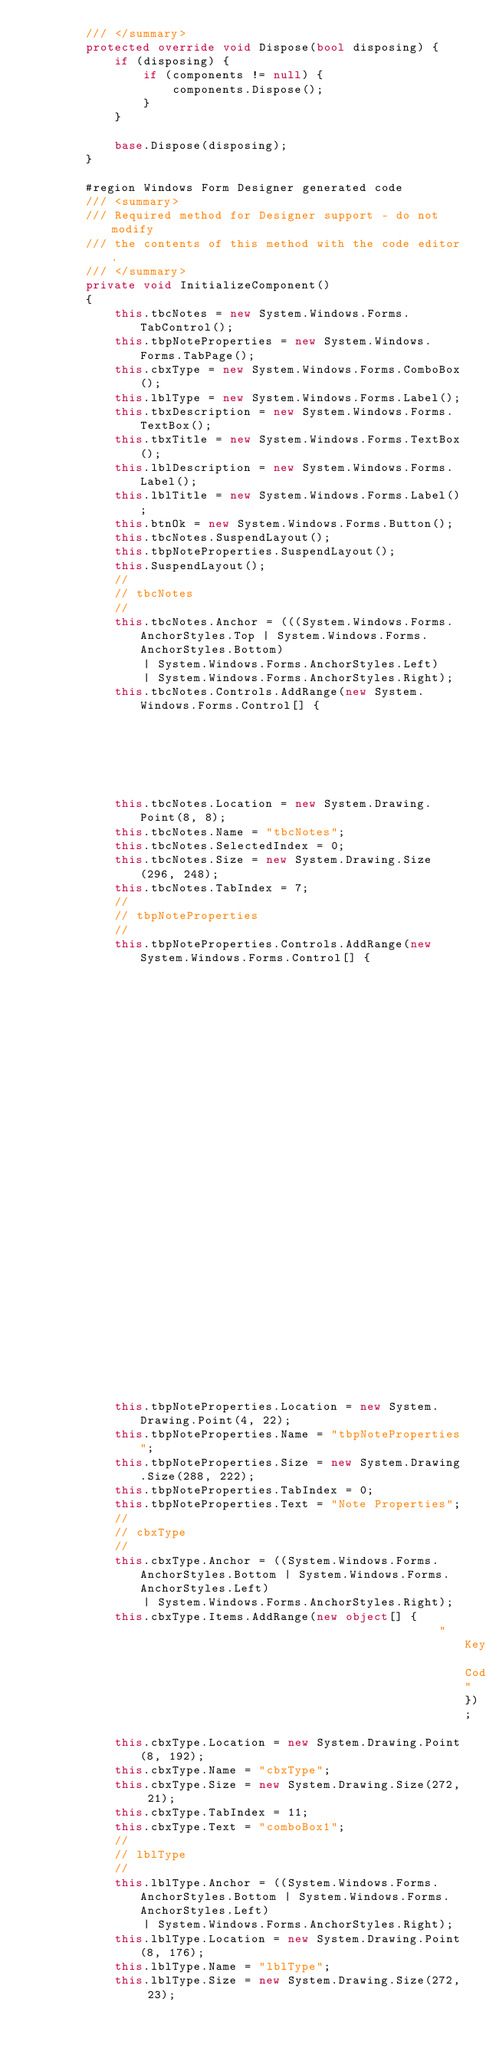Convert code to text. <code><loc_0><loc_0><loc_500><loc_500><_C#_>		/// </summary>
		protected override void Dispose(bool disposing) {
			if (disposing) {
				if (components != null) {
					components.Dispose();
				}
			}
			
			base.Dispose(disposing);
		}
		
		#region Windows Form Designer generated code
		/// <summary>
		/// Required method for Designer support - do not modify
		/// the contents of this method with the code editor.
		/// </summary>
		private void InitializeComponent()
		{
			this.tbcNotes = new System.Windows.Forms.TabControl();
			this.tbpNoteProperties = new System.Windows.Forms.TabPage();
			this.cbxType = new System.Windows.Forms.ComboBox();
			this.lblType = new System.Windows.Forms.Label();
			this.tbxDescription = new System.Windows.Forms.TextBox();
			this.tbxTitle = new System.Windows.Forms.TextBox();
			this.lblDescription = new System.Windows.Forms.Label();
			this.lblTitle = new System.Windows.Forms.Label();
			this.btnOk = new System.Windows.Forms.Button();
			this.tbcNotes.SuspendLayout();
			this.tbpNoteProperties.SuspendLayout();
			this.SuspendLayout();
			// 
			// tbcNotes
			// 
			this.tbcNotes.Anchor = (((System.Windows.Forms.AnchorStyles.Top | System.Windows.Forms.AnchorStyles.Bottom) 
				| System.Windows.Forms.AnchorStyles.Left) 
				| System.Windows.Forms.AnchorStyles.Right);
			this.tbcNotes.Controls.AddRange(new System.Windows.Forms.Control[] {
																				   this.tbpNoteProperties});
			this.tbcNotes.Location = new System.Drawing.Point(8, 8);
			this.tbcNotes.Name = "tbcNotes";
			this.tbcNotes.SelectedIndex = 0;
			this.tbcNotes.Size = new System.Drawing.Size(296, 248);
			this.tbcNotes.TabIndex = 7;
			// 
			// tbpNoteProperties
			// 
			this.tbpNoteProperties.Controls.AddRange(new System.Windows.Forms.Control[] {
																							this.cbxType,
																							this.lblType,
																							this.tbxDescription,
																							this.tbxTitle,
																							this.lblDescription,
																							this.lblTitle});
			this.tbpNoteProperties.Location = new System.Drawing.Point(4, 22);
			this.tbpNoteProperties.Name = "tbpNoteProperties";
			this.tbpNoteProperties.Size = new System.Drawing.Size(288, 222);
			this.tbpNoteProperties.TabIndex = 0;
			this.tbpNoteProperties.Text = "Note Properties";
			// 
			// cbxType
			// 
			this.cbxType.Anchor = ((System.Windows.Forms.AnchorStyles.Bottom | System.Windows.Forms.AnchorStyles.Left) 
				| System.Windows.Forms.AnchorStyles.Right);
			this.cbxType.Items.AddRange(new object[] {
														 "Key Codes"});
			this.cbxType.Location = new System.Drawing.Point(8, 192);
			this.cbxType.Name = "cbxType";
			this.cbxType.Size = new System.Drawing.Size(272, 21);
			this.cbxType.TabIndex = 11;
			this.cbxType.Text = "comboBox1";
			// 
			// lblType
			// 
			this.lblType.Anchor = ((System.Windows.Forms.AnchorStyles.Bottom | System.Windows.Forms.AnchorStyles.Left) 
				| System.Windows.Forms.AnchorStyles.Right);
			this.lblType.Location = new System.Drawing.Point(8, 176);
			this.lblType.Name = "lblType";
			this.lblType.Size = new System.Drawing.Size(272, 23);</code> 